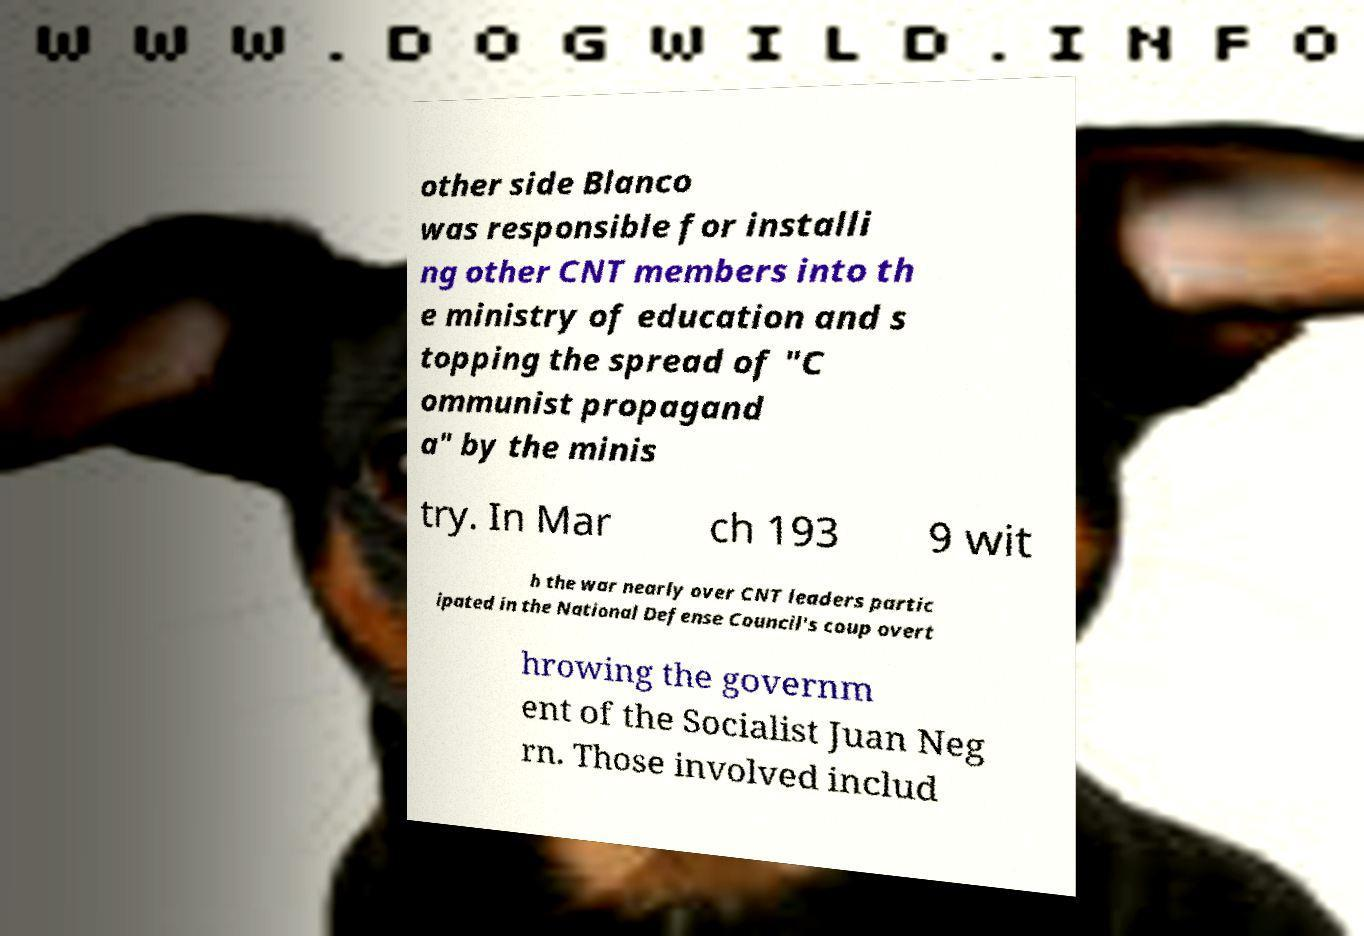Please read and relay the text visible in this image. What does it say? other side Blanco was responsible for installi ng other CNT members into th e ministry of education and s topping the spread of "C ommunist propagand a" by the minis try. In Mar ch 193 9 wit h the war nearly over CNT leaders partic ipated in the National Defense Council's coup overt hrowing the governm ent of the Socialist Juan Neg rn. Those involved includ 